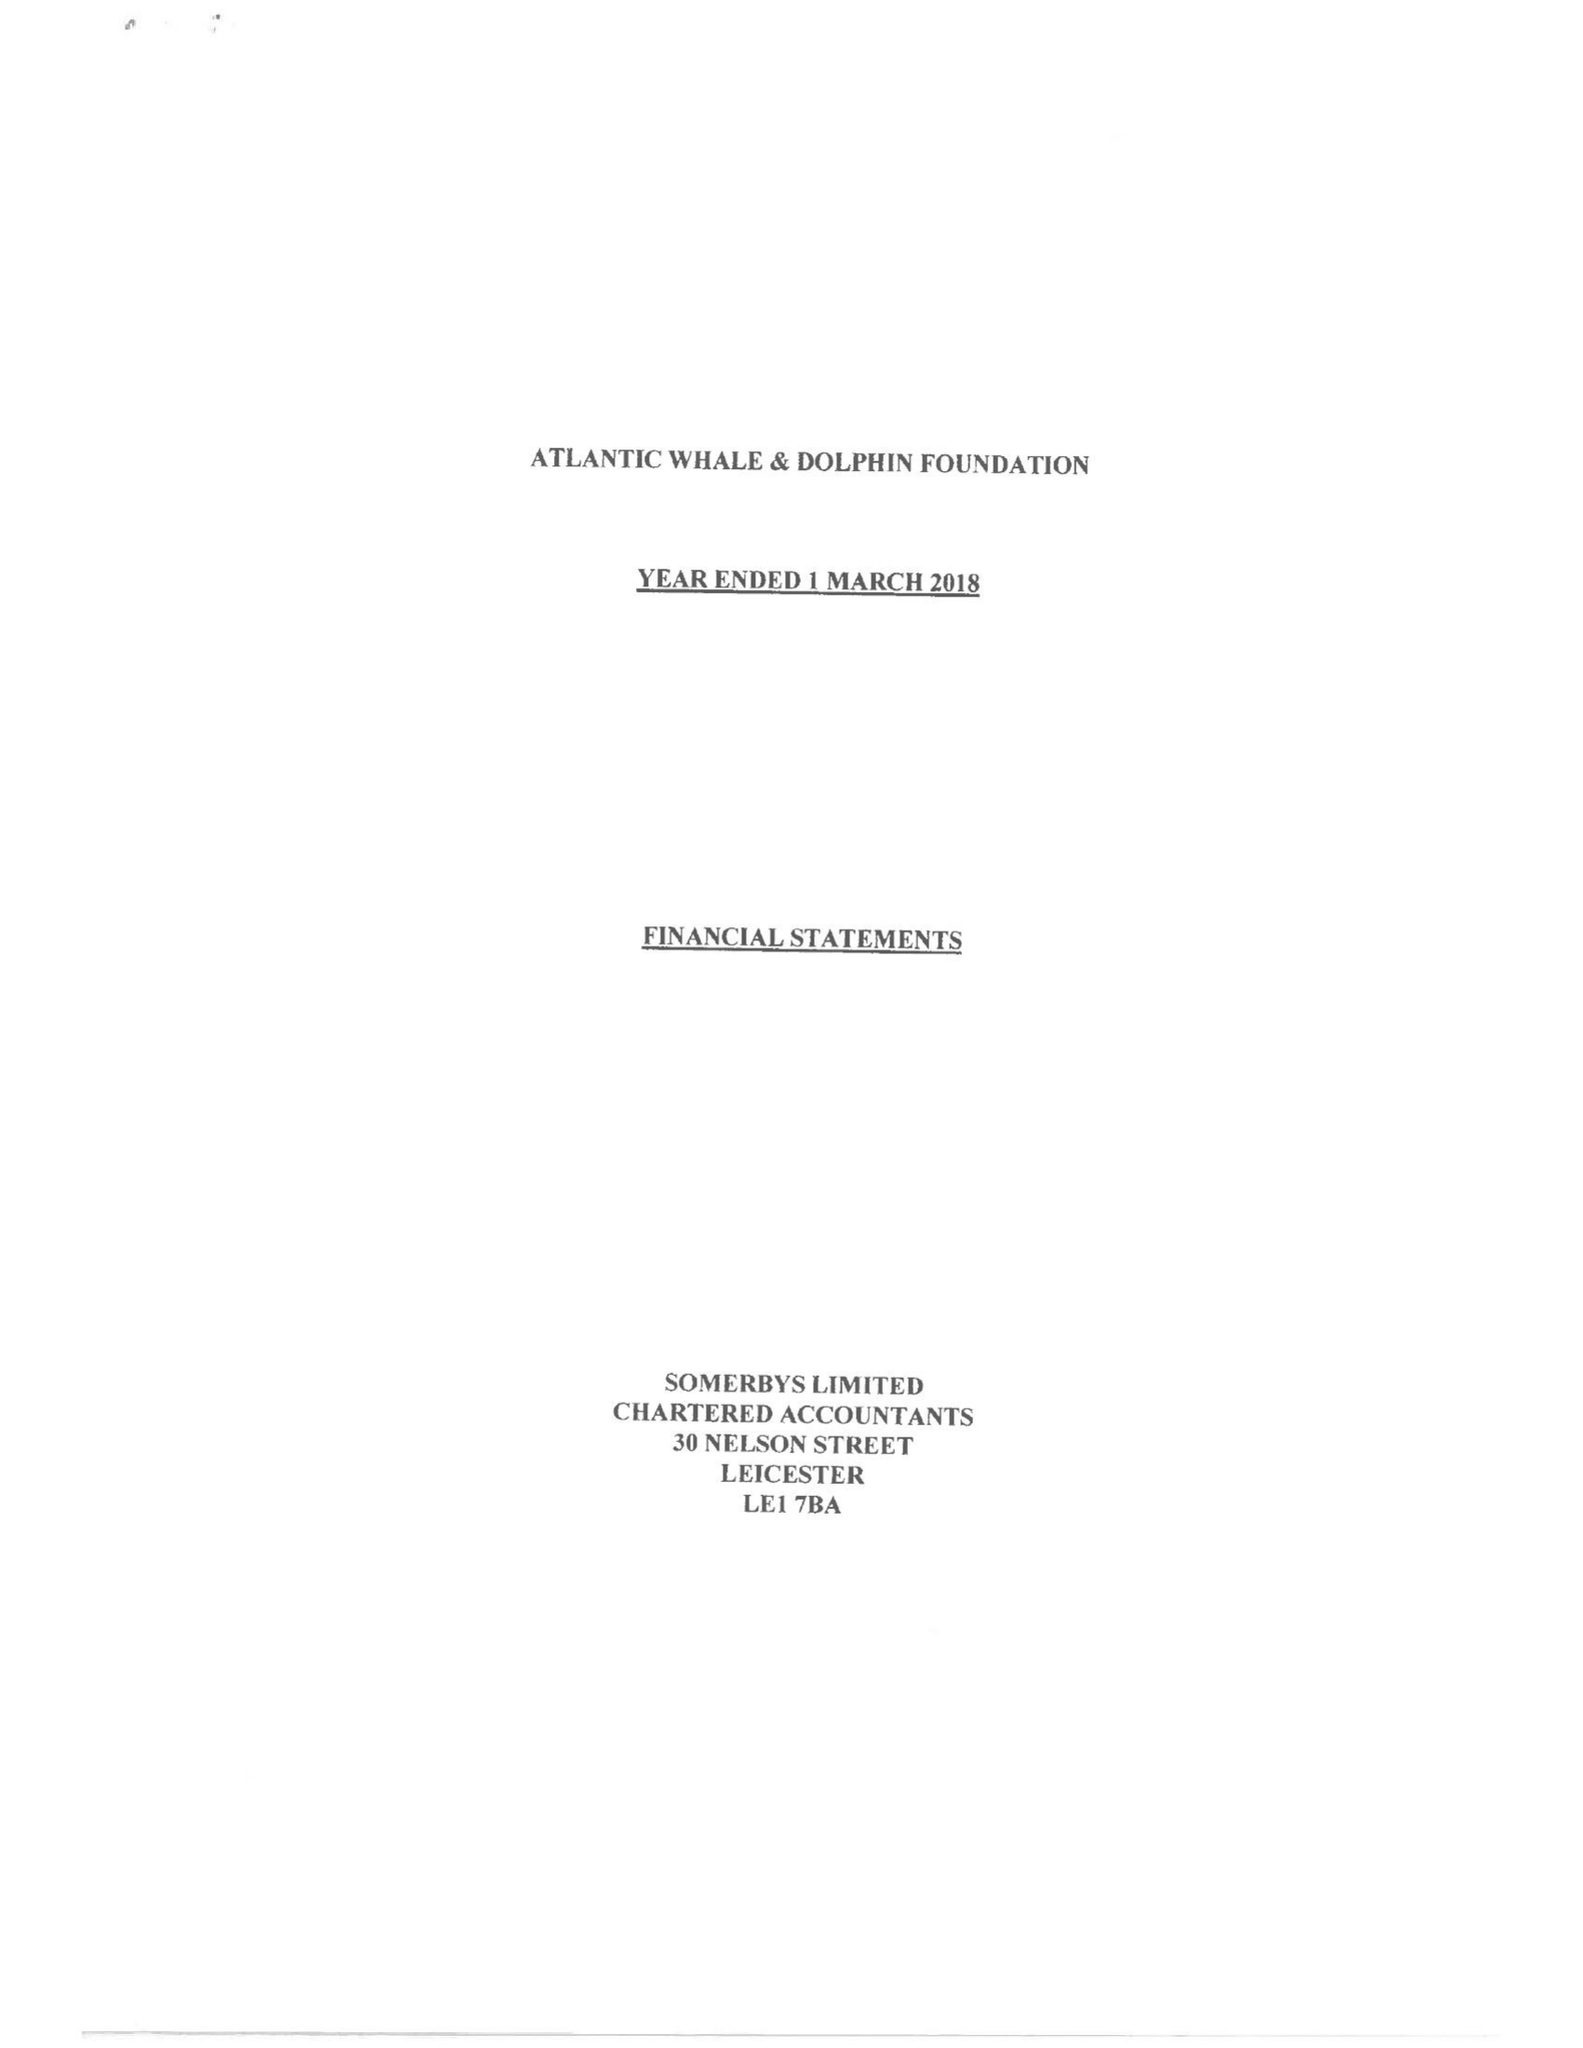What is the value for the report_date?
Answer the question using a single word or phrase. 2018-03-01 